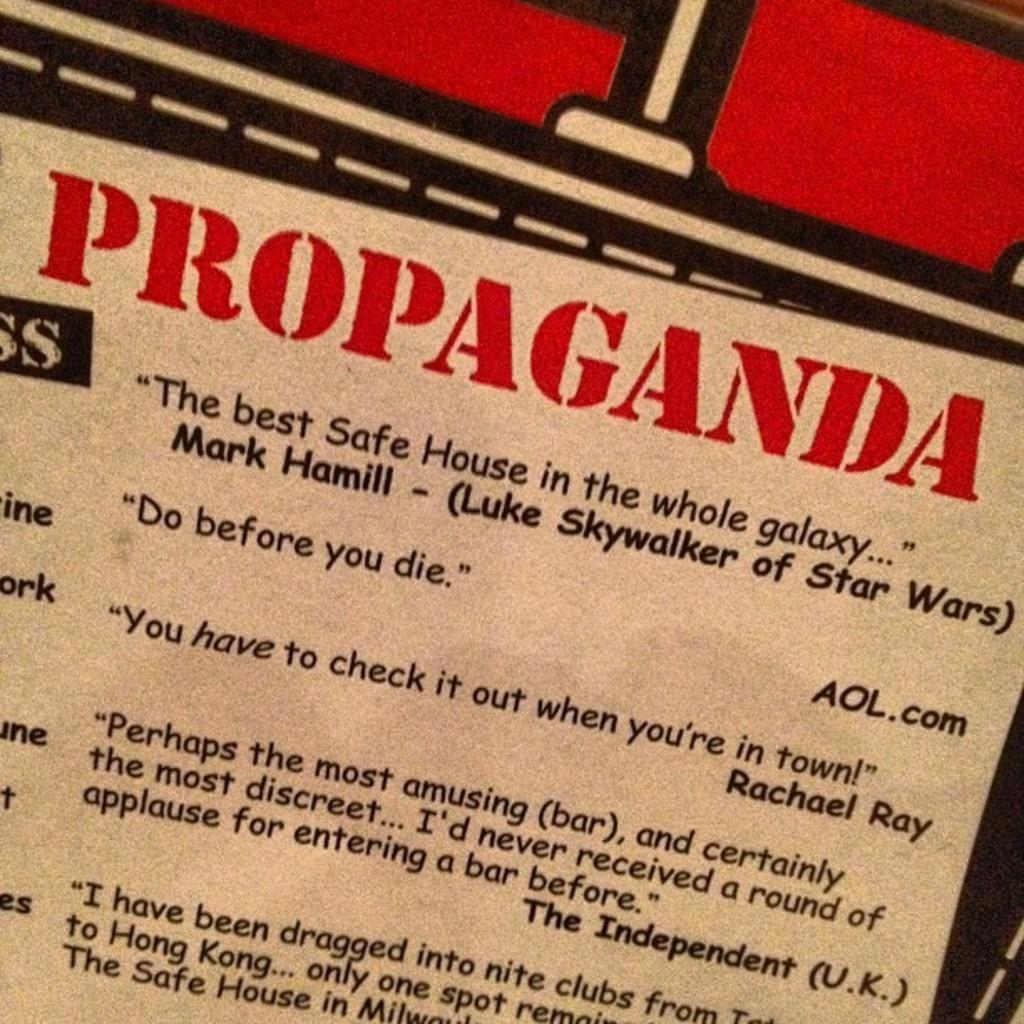What is written in red?
Provide a succinct answer. Propaganda. 